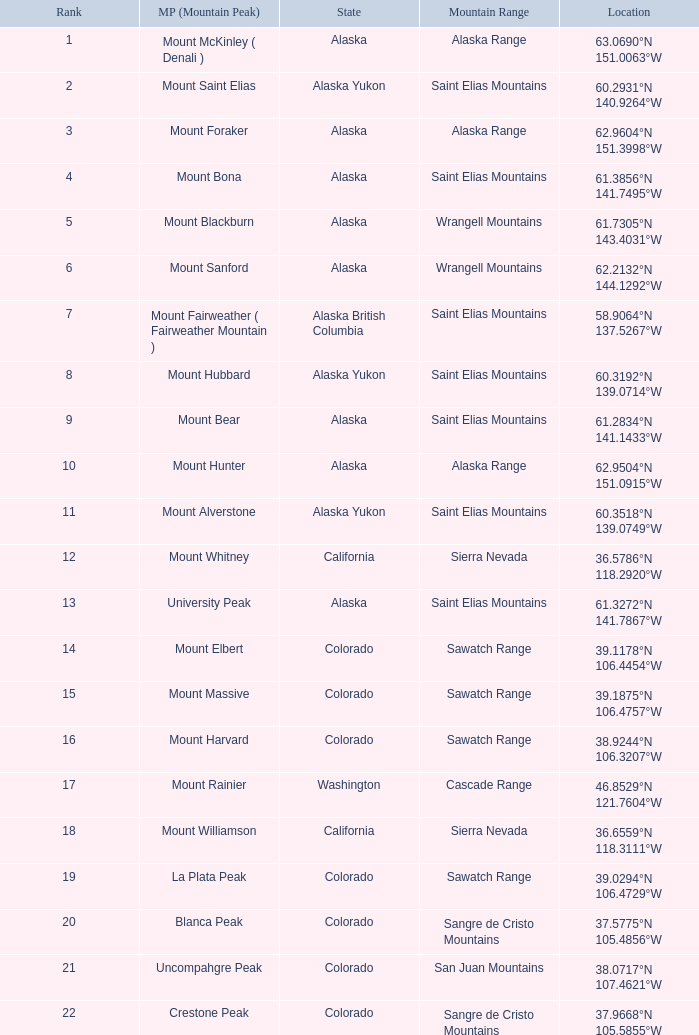What is the mountain peak when the location is 37.5775°n 105.4856°w? Blanca Peak. 